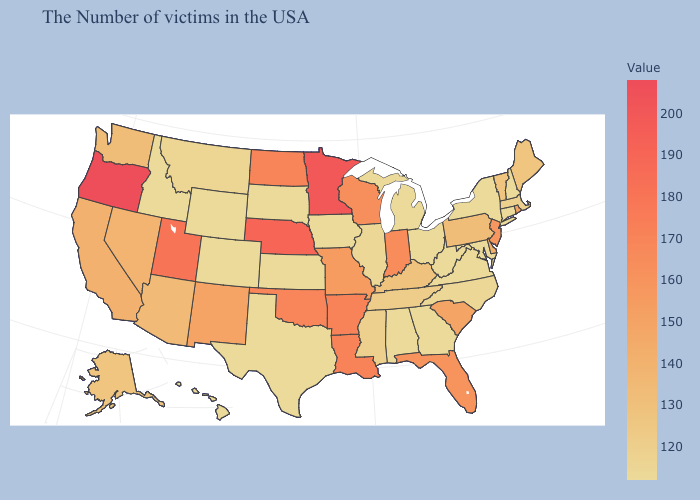Which states have the highest value in the USA?
Concise answer only. Oregon. Which states have the highest value in the USA?
Short answer required. Oregon. Does the map have missing data?
Keep it brief. No. Which states hav the highest value in the Northeast?
Keep it brief. New Jersey. 